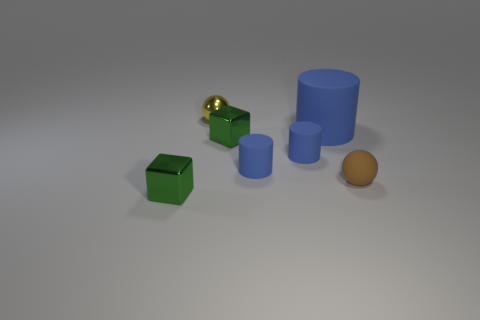Is there another object that has the same color as the big thing?
Give a very brief answer. Yes. Is the size of the brown ball the same as the shiny sphere?
Make the answer very short. Yes. There is a brown object on the right side of the cube behind the brown thing; what is it made of?
Make the answer very short. Rubber. There is a small yellow object that is the same shape as the tiny brown thing; what is it made of?
Your answer should be very brief. Metal. There is a yellow shiny object behind the brown rubber thing; is its size the same as the brown matte thing?
Provide a succinct answer. Yes. How many matte things are either balls or yellow balls?
Give a very brief answer. 1. Is the material of the brown object the same as the large object?
Your answer should be very brief. Yes. There is a metal object that is both in front of the big blue object and behind the matte ball; what is its size?
Your answer should be very brief. Small. What is the shape of the yellow metal thing?
Provide a succinct answer. Sphere. How many objects are either large brown objects or tiny matte things right of the large blue rubber cylinder?
Your response must be concise. 1. 